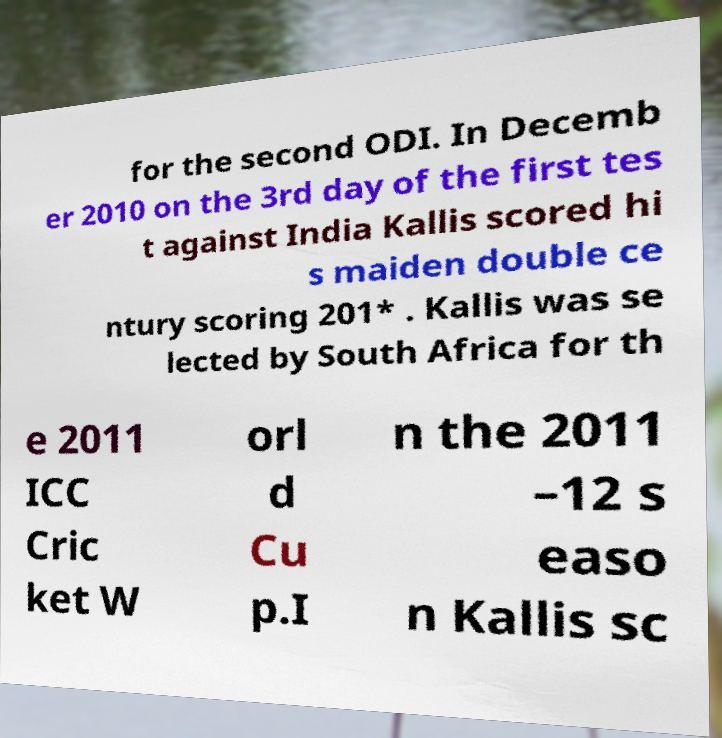I need the written content from this picture converted into text. Can you do that? for the second ODI. In Decemb er 2010 on the 3rd day of the first tes t against India Kallis scored hi s maiden double ce ntury scoring 201* . Kallis was se lected by South Africa for th e 2011 ICC Cric ket W orl d Cu p.I n the 2011 –12 s easo n Kallis sc 